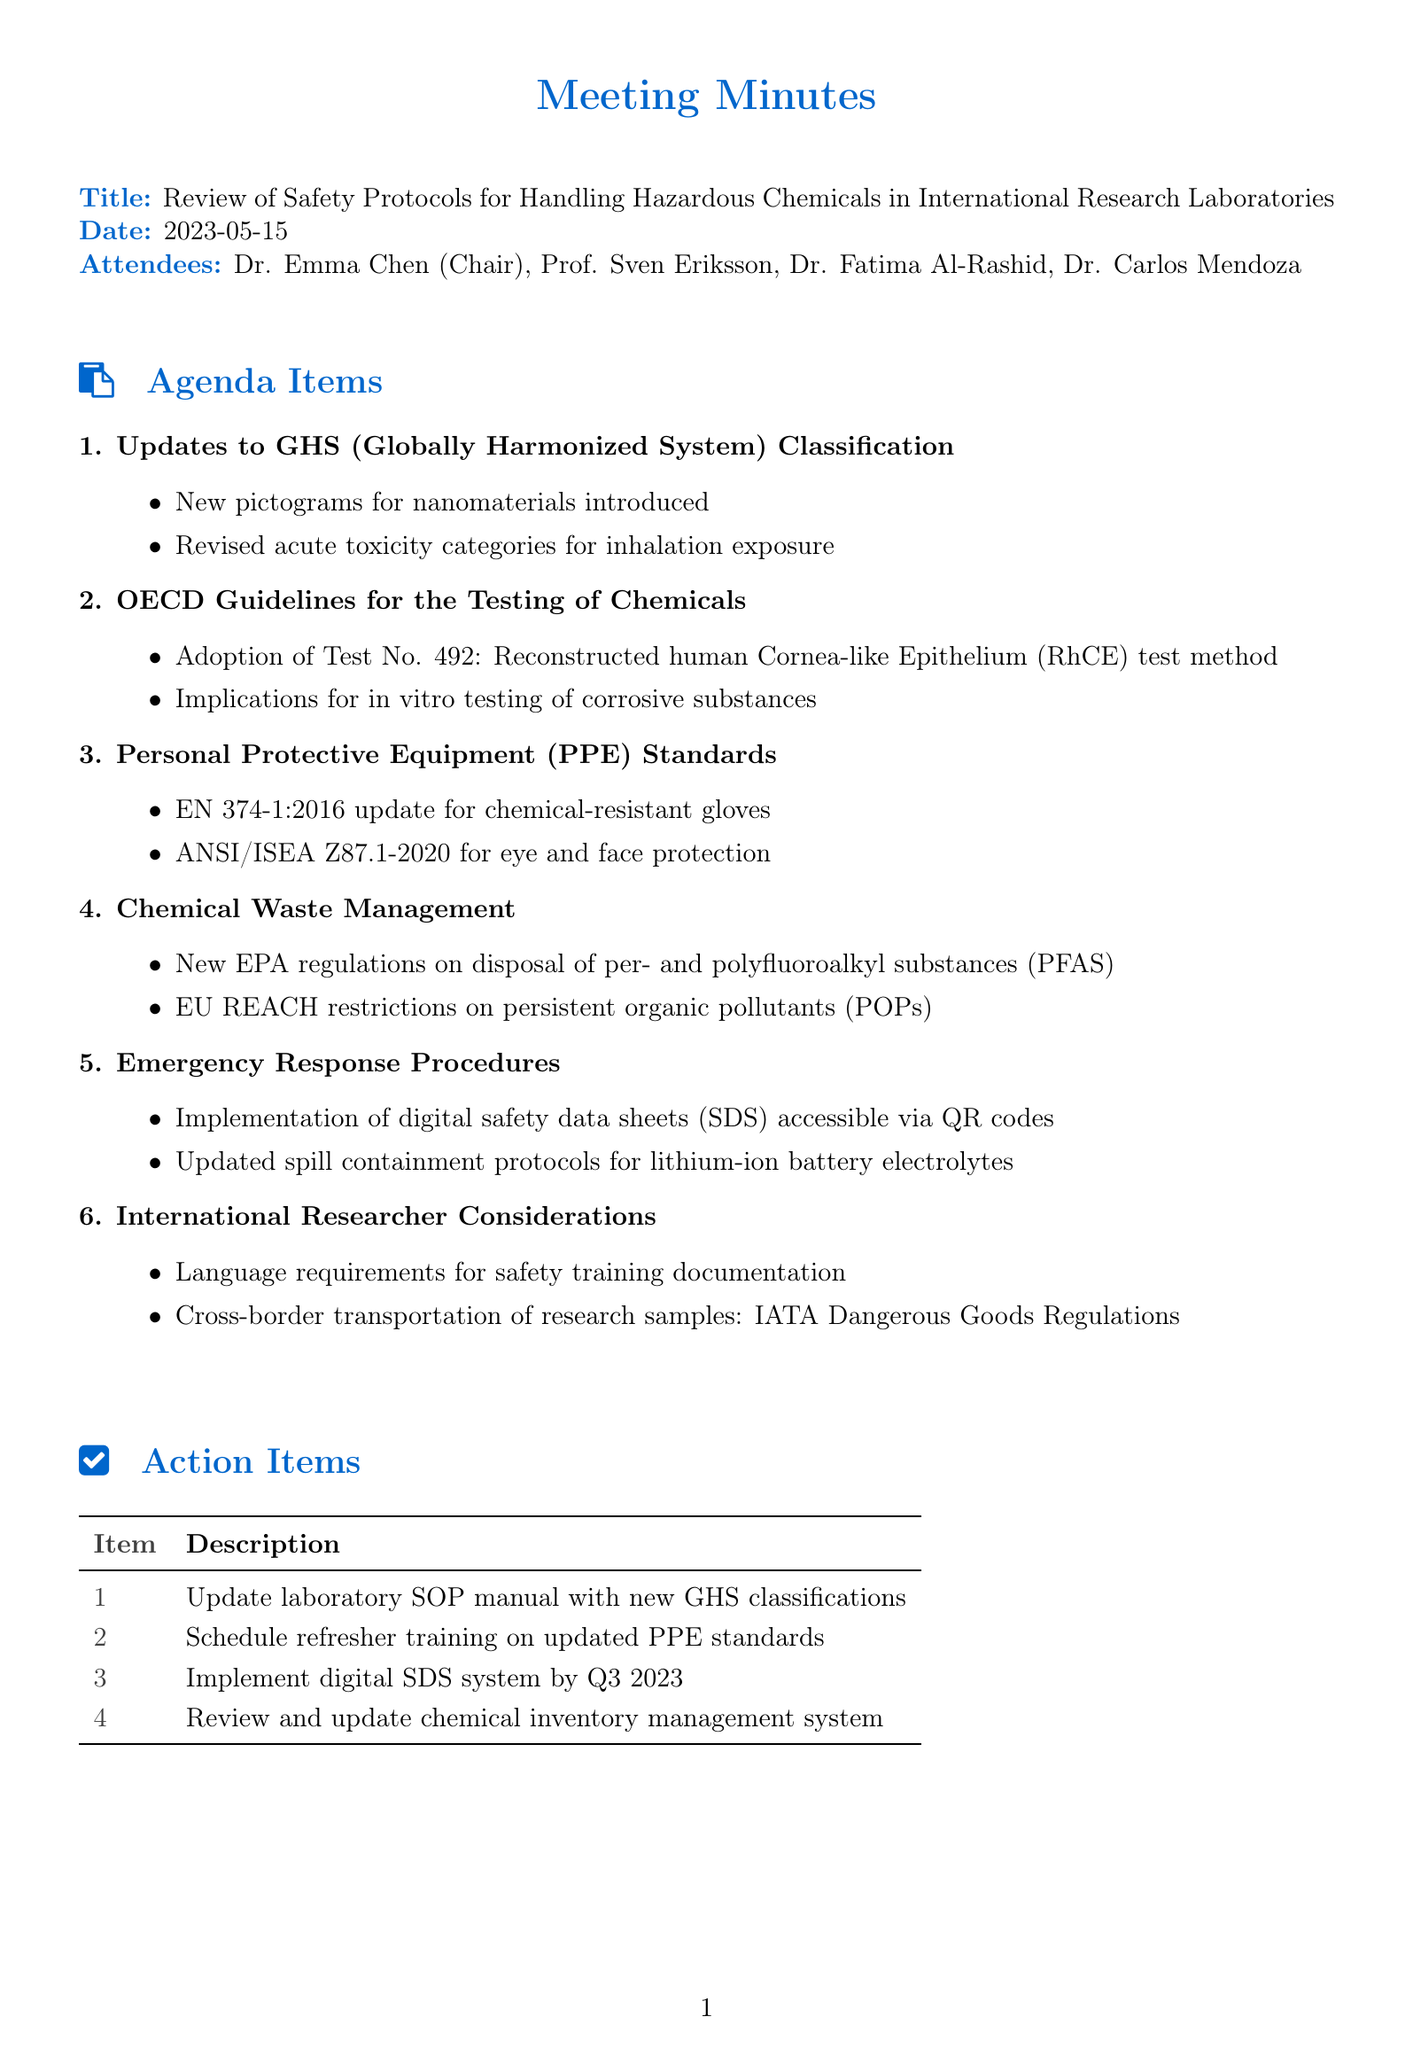What is the date of the meeting? The date of the meeting is provided in the document.
Answer: 2023-05-15 Who chaired the meeting? The attendees include the chair, which is explicitly mentioned in the document.
Answer: Dr. Emma Chen What is one of the topics discussed related to PPE standards? The document provides specific updates on PPE standards, indicating significant changes.
Answer: EN 374-1:2016 update for chemical-resistant gloves What new regulation is mentioned regarding chemical waste management? The document lists updates on regulations concerning chemical waste management specifically.
Answer: New EPA regulations on disposal of per- and polyfluoroalkyl substances (PFAS) What two topics are included under "International Researcher Considerations"? The document explicitly lists topics discussed concerning international researchers, requiring synthesis of knowledge.
Answer: Language requirements for safety training documentation, Cross-border transportation of research samples: IATA Dangerous Goods Regulations How many action items are listed in the document? The document provides a section that outlines the number of action items identified.
Answer: 4 